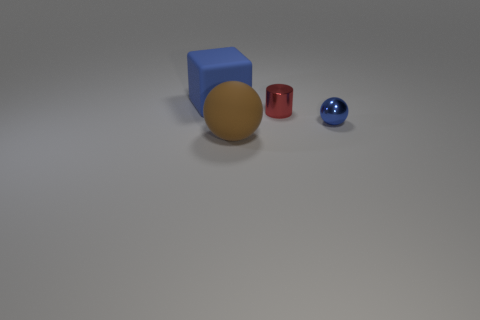What could be the purpose of arranging these objects like this? This arrangement could be part of a visual experiment or demonstration related to topics such as color perception, material properties, or geometric shapes. It provides a simple yet effective way to compare and contrast these elements. 